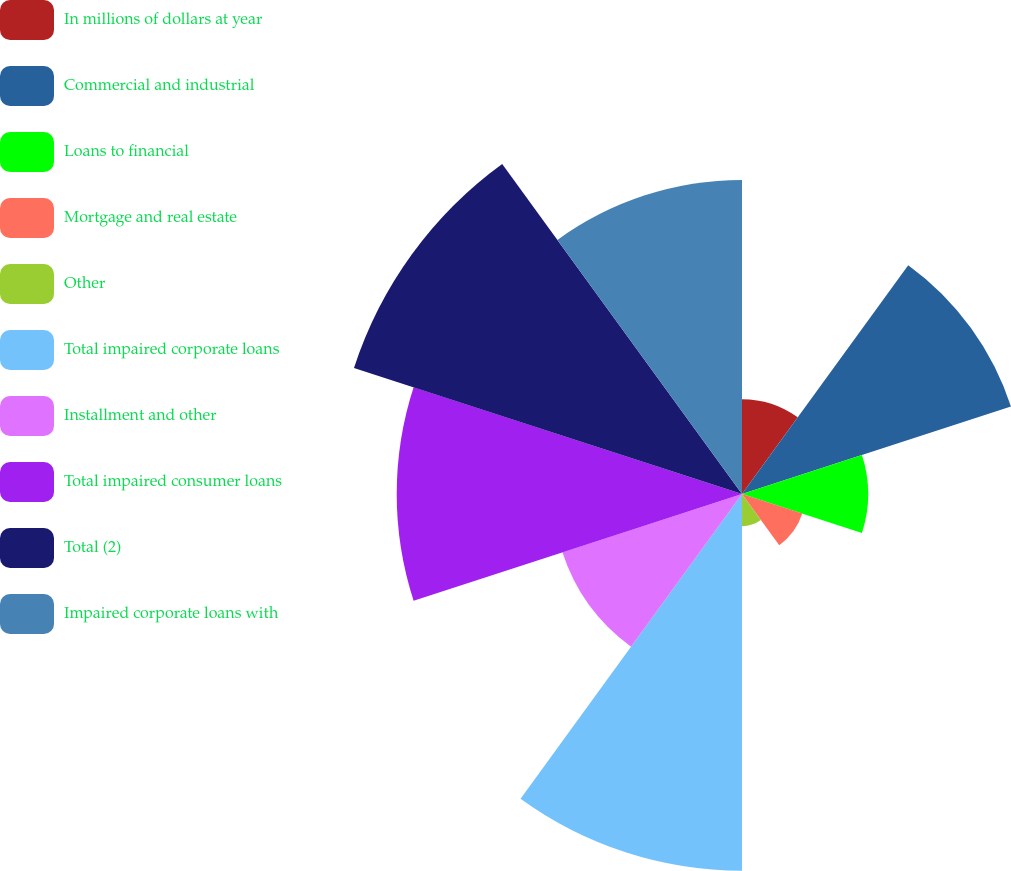Convert chart to OTSL. <chart><loc_0><loc_0><loc_500><loc_500><pie_chart><fcel>In millions of dollars at year<fcel>Commercial and industrial<fcel>Loans to financial<fcel>Mortgage and real estate<fcel>Other<fcel>Total impaired corporate loans<fcel>Installment and other<fcel>Total impaired consumer loans<fcel>Total (2)<fcel>Impaired corporate loans with<nl><fcel>4.25%<fcel>12.67%<fcel>5.65%<fcel>2.84%<fcel>1.44%<fcel>16.88%<fcel>8.46%<fcel>15.47%<fcel>18.28%<fcel>14.07%<nl></chart> 